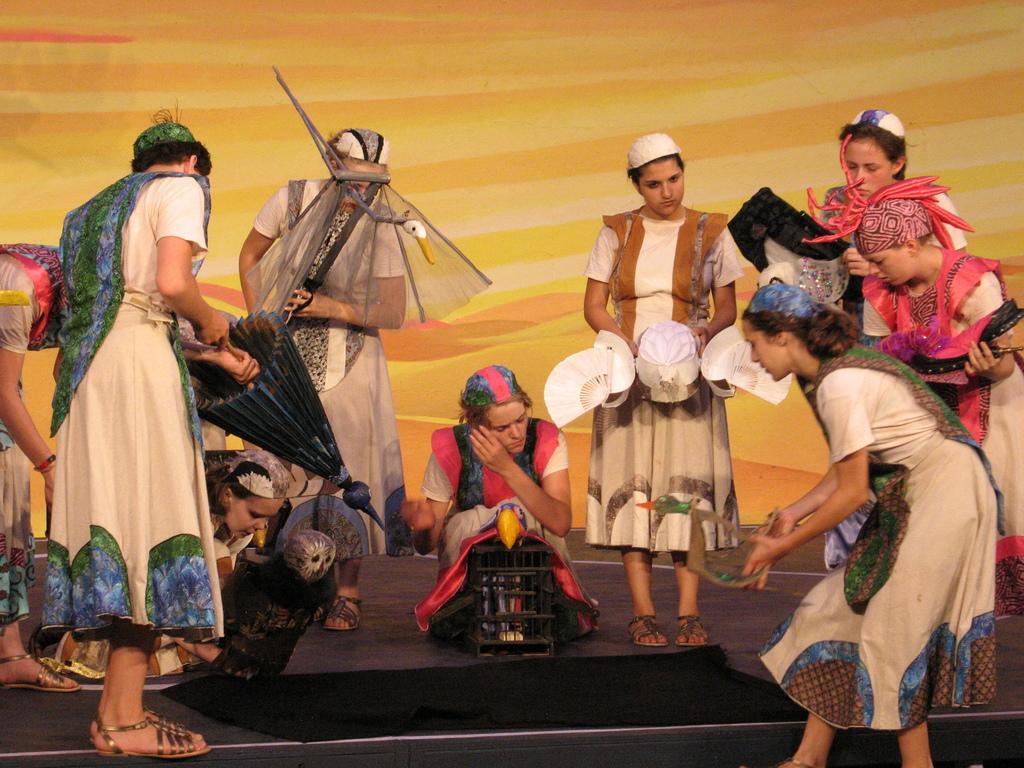Can you describe this image briefly? In this image we can see a few people holding some objects, in the background we can see the wall. 